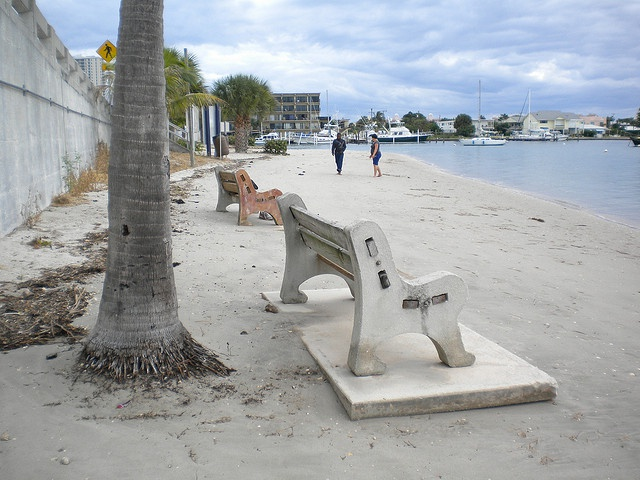Describe the objects in this image and their specific colors. I can see bench in gray, darkgray, and lightgray tones, bench in gray and darkgray tones, boat in gray, lightgray, darkgray, black, and navy tones, boat in gray, lightgray, and darkgray tones, and people in gray, black, navy, and white tones in this image. 